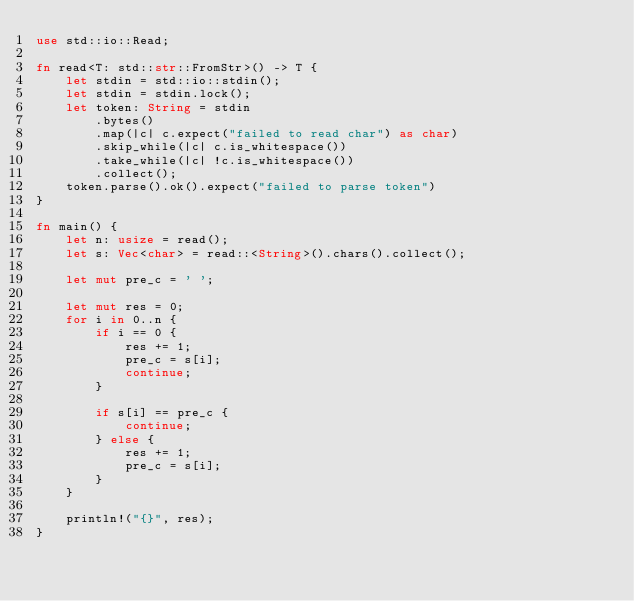<code> <loc_0><loc_0><loc_500><loc_500><_Rust_>use std::io::Read;

fn read<T: std::str::FromStr>() -> T {
    let stdin = std::io::stdin();
    let stdin = stdin.lock();
    let token: String = stdin
        .bytes()
        .map(|c| c.expect("failed to read char") as char)
        .skip_while(|c| c.is_whitespace())
        .take_while(|c| !c.is_whitespace())
        .collect();
    token.parse().ok().expect("failed to parse token")
}

fn main() {
    let n: usize = read();
    let s: Vec<char> = read::<String>().chars().collect();

    let mut pre_c = ' ';

    let mut res = 0;
    for i in 0..n {
        if i == 0 {
            res += 1;
            pre_c = s[i];
            continue;
        }

        if s[i] == pre_c {
            continue;
        } else {
            res += 1;
            pre_c = s[i];
        }
    }

    println!("{}", res);
}
</code> 